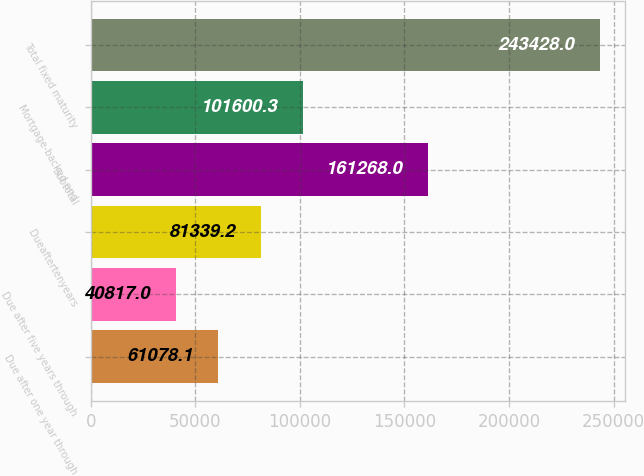<chart> <loc_0><loc_0><loc_500><loc_500><bar_chart><fcel>Due after one year through<fcel>Due after five years through<fcel>Dueaftertenyears<fcel>Subtotal<fcel>Mortgage-backed and<fcel>Total fixed maturity<nl><fcel>61078.1<fcel>40817<fcel>81339.2<fcel>161268<fcel>101600<fcel>243428<nl></chart> 